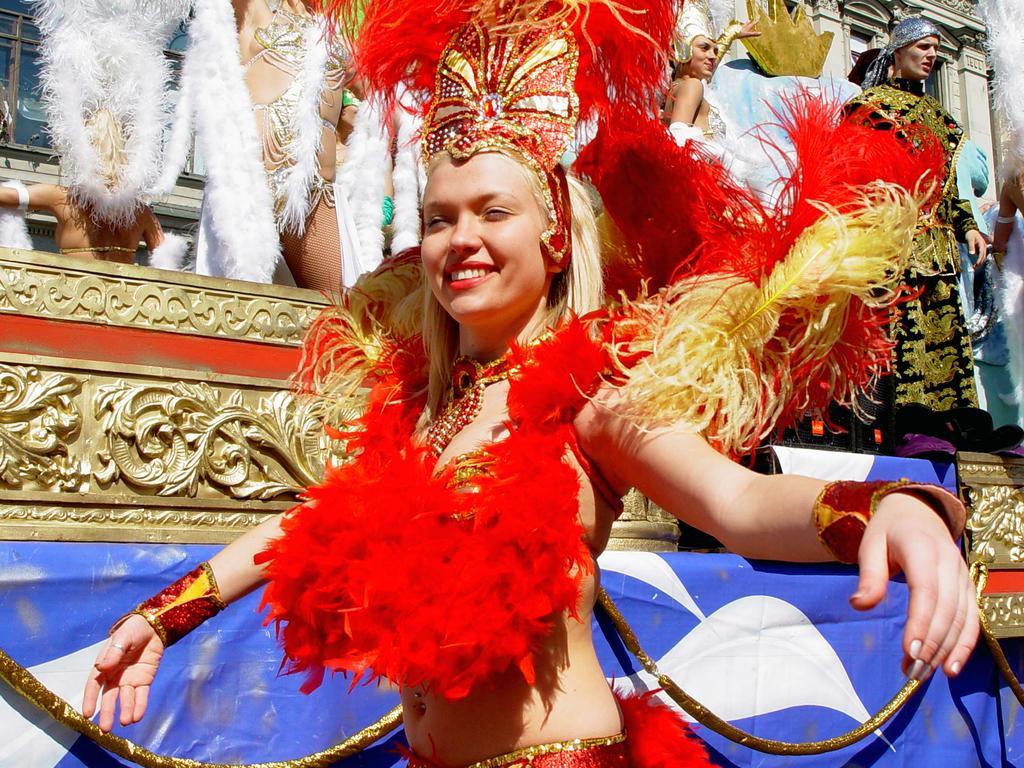Can you describe this image briefly? In this picture we can see a woman wore a costume and standing and smiling and in the background we can see some people. 